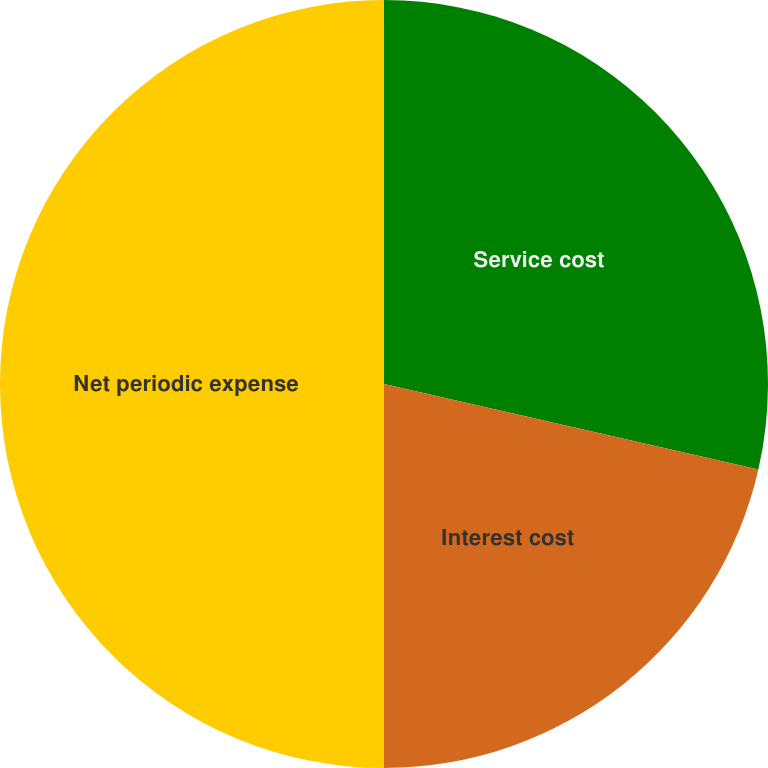Convert chart to OTSL. <chart><loc_0><loc_0><loc_500><loc_500><pie_chart><fcel>Service cost<fcel>Interest cost<fcel>Net periodic expense<nl><fcel>28.57%<fcel>21.43%<fcel>50.0%<nl></chart> 